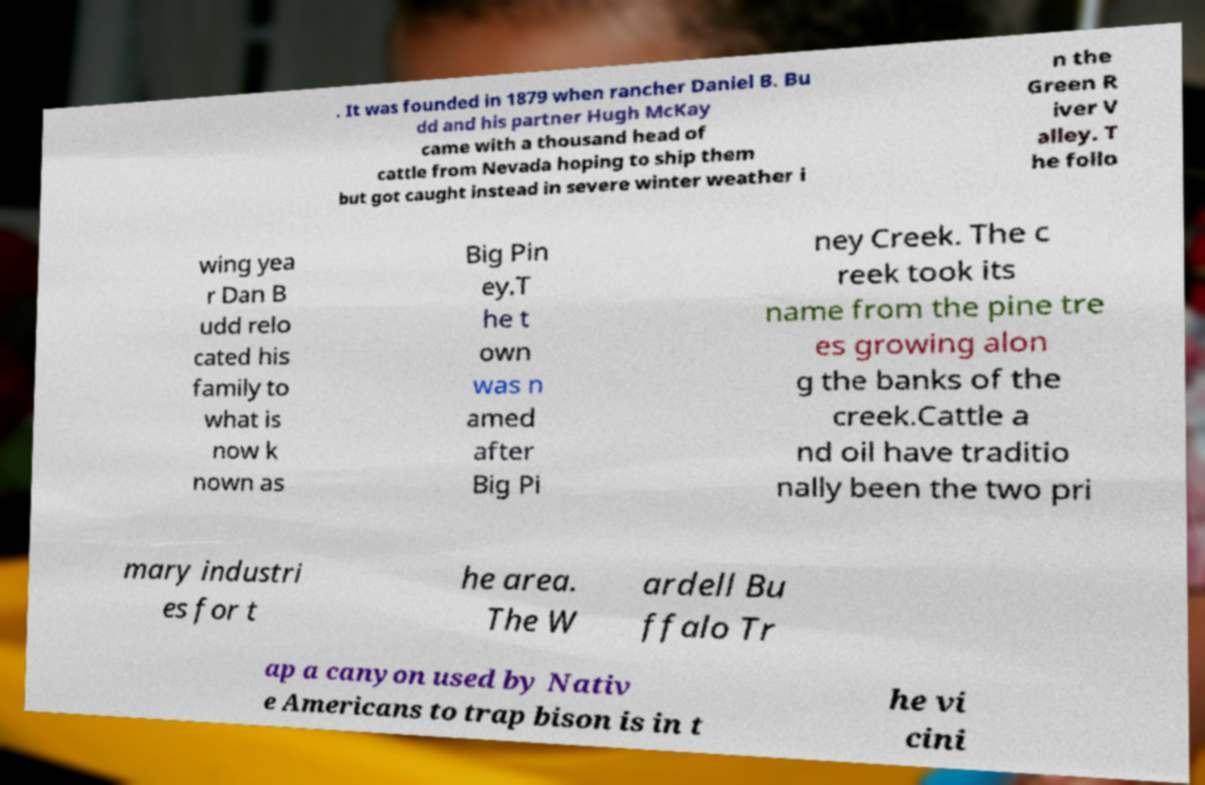Can you accurately transcribe the text from the provided image for me? . It was founded in 1879 when rancher Daniel B. Bu dd and his partner Hugh McKay came with a thousand head of cattle from Nevada hoping to ship them but got caught instead in severe winter weather i n the Green R iver V alley. T he follo wing yea r Dan B udd relo cated his family to what is now k nown as Big Pin ey.T he t own was n amed after Big Pi ney Creek. The c reek took its name from the pine tre es growing alon g the banks of the creek.Cattle a nd oil have traditio nally been the two pri mary industri es for t he area. The W ardell Bu ffalo Tr ap a canyon used by Nativ e Americans to trap bison is in t he vi cini 